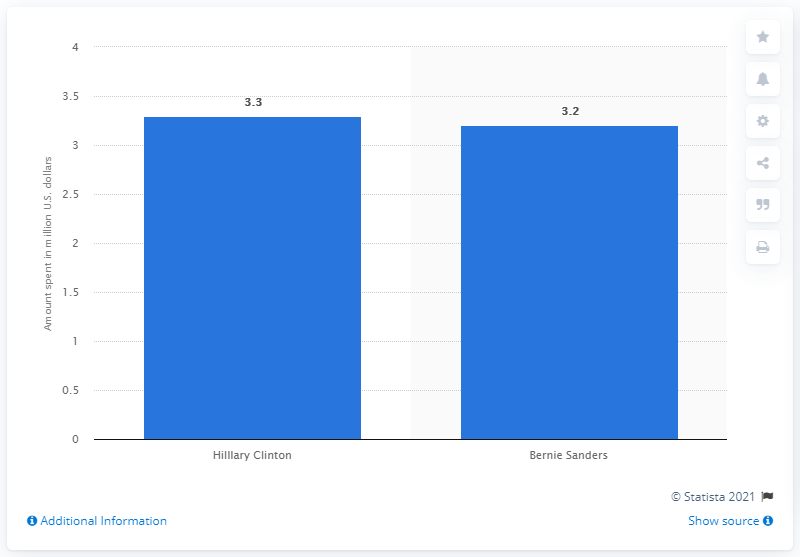Indicate a few pertinent items in this graphic. Hillary Clinton spent more on television ads than Bernie Sanders, who she outspent in the 2016 presidential election. 